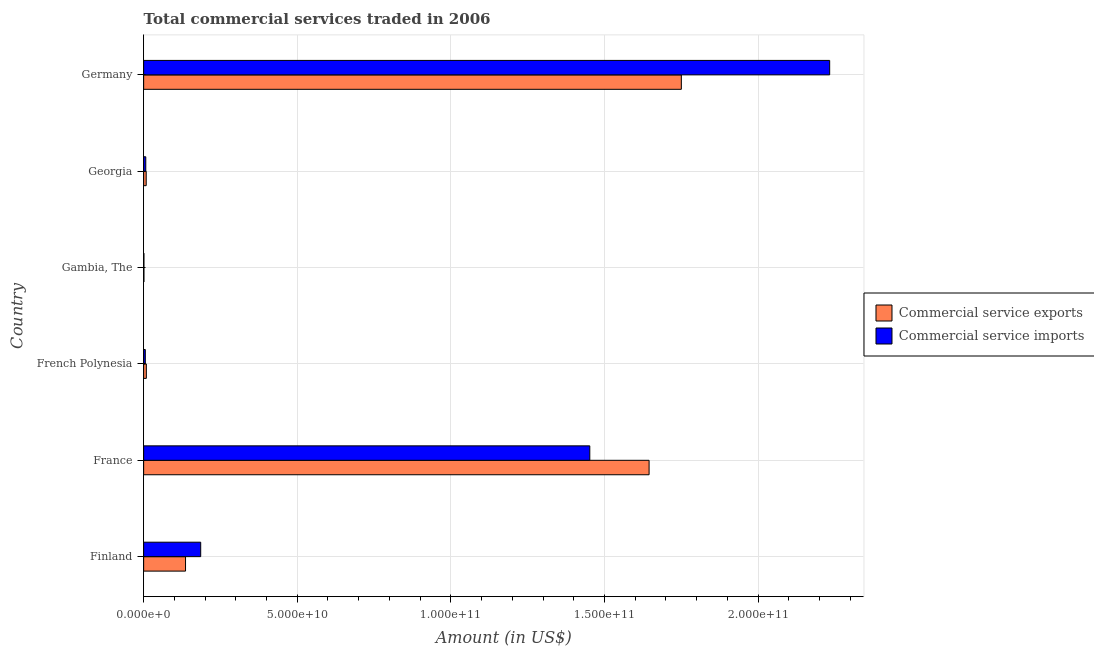How many groups of bars are there?
Your response must be concise. 6. Are the number of bars per tick equal to the number of legend labels?
Your answer should be very brief. Yes. How many bars are there on the 2nd tick from the bottom?
Offer a very short reply. 2. What is the label of the 4th group of bars from the top?
Keep it short and to the point. French Polynesia. In how many cases, is the number of bars for a given country not equal to the number of legend labels?
Offer a terse response. 0. What is the amount of commercial service exports in Germany?
Offer a terse response. 1.75e+11. Across all countries, what is the maximum amount of commercial service imports?
Provide a succinct answer. 2.23e+11. Across all countries, what is the minimum amount of commercial service imports?
Offer a very short reply. 9.41e+07. In which country was the amount of commercial service exports maximum?
Provide a succinct answer. Germany. In which country was the amount of commercial service imports minimum?
Make the answer very short. Gambia, The. What is the total amount of commercial service imports in the graph?
Your response must be concise. 3.88e+11. What is the difference between the amount of commercial service exports in French Polynesia and that in Gambia, The?
Ensure brevity in your answer.  7.84e+08. What is the difference between the amount of commercial service imports in Gambia, The and the amount of commercial service exports in France?
Your response must be concise. -1.64e+11. What is the average amount of commercial service imports per country?
Offer a terse response. 6.47e+1. What is the difference between the amount of commercial service exports and amount of commercial service imports in France?
Provide a succinct answer. 1.93e+1. What is the ratio of the amount of commercial service exports in Finland to that in French Polynesia?
Ensure brevity in your answer.  15.57. What is the difference between the highest and the second highest amount of commercial service imports?
Provide a short and direct response. 7.81e+1. What is the difference between the highest and the lowest amount of commercial service imports?
Ensure brevity in your answer.  2.23e+11. What does the 2nd bar from the top in Finland represents?
Your answer should be compact. Commercial service exports. What does the 2nd bar from the bottom in Georgia represents?
Keep it short and to the point. Commercial service imports. How many bars are there?
Ensure brevity in your answer.  12. Are all the bars in the graph horizontal?
Give a very brief answer. Yes. How many countries are there in the graph?
Keep it short and to the point. 6. What is the difference between two consecutive major ticks on the X-axis?
Give a very brief answer. 5.00e+1. Are the values on the major ticks of X-axis written in scientific E-notation?
Your answer should be very brief. Yes. Does the graph contain any zero values?
Ensure brevity in your answer.  No. Does the graph contain grids?
Offer a very short reply. Yes. How are the legend labels stacked?
Your answer should be very brief. Vertical. What is the title of the graph?
Make the answer very short. Total commercial services traded in 2006. Does "Male population" appear as one of the legend labels in the graph?
Your answer should be compact. No. What is the Amount (in US$) in Commercial service exports in Finland?
Give a very brief answer. 1.36e+1. What is the Amount (in US$) of Commercial service imports in Finland?
Offer a terse response. 1.86e+1. What is the Amount (in US$) of Commercial service exports in France?
Your answer should be very brief. 1.65e+11. What is the Amount (in US$) of Commercial service imports in France?
Your response must be concise. 1.45e+11. What is the Amount (in US$) in Commercial service exports in French Polynesia?
Your answer should be compact. 8.76e+08. What is the Amount (in US$) in Commercial service imports in French Polynesia?
Offer a terse response. 5.42e+08. What is the Amount (in US$) of Commercial service exports in Gambia, The?
Your answer should be very brief. 9.21e+07. What is the Amount (in US$) of Commercial service imports in Gambia, The?
Offer a very short reply. 9.41e+07. What is the Amount (in US$) of Commercial service exports in Georgia?
Provide a succinct answer. 8.29e+08. What is the Amount (in US$) in Commercial service imports in Georgia?
Offer a very short reply. 6.93e+08. What is the Amount (in US$) in Commercial service exports in Germany?
Offer a very short reply. 1.75e+11. What is the Amount (in US$) in Commercial service imports in Germany?
Provide a short and direct response. 2.23e+11. Across all countries, what is the maximum Amount (in US$) in Commercial service exports?
Provide a short and direct response. 1.75e+11. Across all countries, what is the maximum Amount (in US$) in Commercial service imports?
Your answer should be compact. 2.23e+11. Across all countries, what is the minimum Amount (in US$) of Commercial service exports?
Provide a short and direct response. 9.21e+07. Across all countries, what is the minimum Amount (in US$) of Commercial service imports?
Make the answer very short. 9.41e+07. What is the total Amount (in US$) in Commercial service exports in the graph?
Offer a terse response. 3.55e+11. What is the total Amount (in US$) of Commercial service imports in the graph?
Keep it short and to the point. 3.88e+11. What is the difference between the Amount (in US$) of Commercial service exports in Finland and that in France?
Keep it short and to the point. -1.51e+11. What is the difference between the Amount (in US$) in Commercial service imports in Finland and that in France?
Your answer should be compact. -1.27e+11. What is the difference between the Amount (in US$) in Commercial service exports in Finland and that in French Polynesia?
Provide a short and direct response. 1.28e+1. What is the difference between the Amount (in US$) of Commercial service imports in Finland and that in French Polynesia?
Your answer should be very brief. 1.80e+1. What is the difference between the Amount (in US$) of Commercial service exports in Finland and that in Gambia, The?
Offer a terse response. 1.35e+1. What is the difference between the Amount (in US$) of Commercial service imports in Finland and that in Gambia, The?
Offer a very short reply. 1.85e+1. What is the difference between the Amount (in US$) in Commercial service exports in Finland and that in Georgia?
Your answer should be very brief. 1.28e+1. What is the difference between the Amount (in US$) of Commercial service imports in Finland and that in Georgia?
Keep it short and to the point. 1.79e+1. What is the difference between the Amount (in US$) in Commercial service exports in Finland and that in Germany?
Your answer should be compact. -1.61e+11. What is the difference between the Amount (in US$) in Commercial service imports in Finland and that in Germany?
Provide a short and direct response. -2.05e+11. What is the difference between the Amount (in US$) of Commercial service exports in France and that in French Polynesia?
Your answer should be very brief. 1.64e+11. What is the difference between the Amount (in US$) of Commercial service imports in France and that in French Polynesia?
Offer a terse response. 1.45e+11. What is the difference between the Amount (in US$) of Commercial service exports in France and that in Gambia, The?
Make the answer very short. 1.64e+11. What is the difference between the Amount (in US$) of Commercial service imports in France and that in Gambia, The?
Provide a short and direct response. 1.45e+11. What is the difference between the Amount (in US$) in Commercial service exports in France and that in Georgia?
Keep it short and to the point. 1.64e+11. What is the difference between the Amount (in US$) of Commercial service imports in France and that in Georgia?
Provide a succinct answer. 1.45e+11. What is the difference between the Amount (in US$) of Commercial service exports in France and that in Germany?
Keep it short and to the point. -1.05e+1. What is the difference between the Amount (in US$) of Commercial service imports in France and that in Germany?
Make the answer very short. -7.81e+1. What is the difference between the Amount (in US$) in Commercial service exports in French Polynesia and that in Gambia, The?
Make the answer very short. 7.84e+08. What is the difference between the Amount (in US$) in Commercial service imports in French Polynesia and that in Gambia, The?
Your answer should be compact. 4.48e+08. What is the difference between the Amount (in US$) in Commercial service exports in French Polynesia and that in Georgia?
Keep it short and to the point. 4.66e+07. What is the difference between the Amount (in US$) of Commercial service imports in French Polynesia and that in Georgia?
Offer a terse response. -1.51e+08. What is the difference between the Amount (in US$) of Commercial service exports in French Polynesia and that in Germany?
Keep it short and to the point. -1.74e+11. What is the difference between the Amount (in US$) in Commercial service imports in French Polynesia and that in Germany?
Your answer should be very brief. -2.23e+11. What is the difference between the Amount (in US$) in Commercial service exports in Gambia, The and that in Georgia?
Your answer should be very brief. -7.37e+08. What is the difference between the Amount (in US$) in Commercial service imports in Gambia, The and that in Georgia?
Provide a succinct answer. -5.99e+08. What is the difference between the Amount (in US$) of Commercial service exports in Gambia, The and that in Germany?
Your answer should be very brief. -1.75e+11. What is the difference between the Amount (in US$) in Commercial service imports in Gambia, The and that in Germany?
Your answer should be very brief. -2.23e+11. What is the difference between the Amount (in US$) of Commercial service exports in Georgia and that in Germany?
Ensure brevity in your answer.  -1.74e+11. What is the difference between the Amount (in US$) of Commercial service imports in Georgia and that in Germany?
Offer a terse response. -2.23e+11. What is the difference between the Amount (in US$) in Commercial service exports in Finland and the Amount (in US$) in Commercial service imports in France?
Keep it short and to the point. -1.32e+11. What is the difference between the Amount (in US$) of Commercial service exports in Finland and the Amount (in US$) of Commercial service imports in French Polynesia?
Offer a terse response. 1.31e+1. What is the difference between the Amount (in US$) in Commercial service exports in Finland and the Amount (in US$) in Commercial service imports in Gambia, The?
Your answer should be very brief. 1.35e+1. What is the difference between the Amount (in US$) in Commercial service exports in Finland and the Amount (in US$) in Commercial service imports in Georgia?
Provide a succinct answer. 1.29e+1. What is the difference between the Amount (in US$) in Commercial service exports in Finland and the Amount (in US$) in Commercial service imports in Germany?
Keep it short and to the point. -2.10e+11. What is the difference between the Amount (in US$) of Commercial service exports in France and the Amount (in US$) of Commercial service imports in French Polynesia?
Make the answer very short. 1.64e+11. What is the difference between the Amount (in US$) of Commercial service exports in France and the Amount (in US$) of Commercial service imports in Gambia, The?
Make the answer very short. 1.64e+11. What is the difference between the Amount (in US$) of Commercial service exports in France and the Amount (in US$) of Commercial service imports in Georgia?
Your response must be concise. 1.64e+11. What is the difference between the Amount (in US$) in Commercial service exports in France and the Amount (in US$) in Commercial service imports in Germany?
Keep it short and to the point. -5.88e+1. What is the difference between the Amount (in US$) of Commercial service exports in French Polynesia and the Amount (in US$) of Commercial service imports in Gambia, The?
Your answer should be compact. 7.82e+08. What is the difference between the Amount (in US$) in Commercial service exports in French Polynesia and the Amount (in US$) in Commercial service imports in Georgia?
Offer a terse response. 1.83e+08. What is the difference between the Amount (in US$) of Commercial service exports in French Polynesia and the Amount (in US$) of Commercial service imports in Germany?
Ensure brevity in your answer.  -2.22e+11. What is the difference between the Amount (in US$) of Commercial service exports in Gambia, The and the Amount (in US$) of Commercial service imports in Georgia?
Your answer should be compact. -6.01e+08. What is the difference between the Amount (in US$) in Commercial service exports in Gambia, The and the Amount (in US$) in Commercial service imports in Germany?
Your answer should be very brief. -2.23e+11. What is the difference between the Amount (in US$) in Commercial service exports in Georgia and the Amount (in US$) in Commercial service imports in Germany?
Give a very brief answer. -2.22e+11. What is the average Amount (in US$) of Commercial service exports per country?
Offer a very short reply. 5.92e+1. What is the average Amount (in US$) in Commercial service imports per country?
Your answer should be compact. 6.47e+1. What is the difference between the Amount (in US$) in Commercial service exports and Amount (in US$) in Commercial service imports in Finland?
Provide a short and direct response. -4.93e+09. What is the difference between the Amount (in US$) of Commercial service exports and Amount (in US$) of Commercial service imports in France?
Provide a succinct answer. 1.93e+1. What is the difference between the Amount (in US$) in Commercial service exports and Amount (in US$) in Commercial service imports in French Polynesia?
Offer a terse response. 3.34e+08. What is the difference between the Amount (in US$) of Commercial service exports and Amount (in US$) of Commercial service imports in Gambia, The?
Your answer should be very brief. -2.00e+06. What is the difference between the Amount (in US$) in Commercial service exports and Amount (in US$) in Commercial service imports in Georgia?
Make the answer very short. 1.36e+08. What is the difference between the Amount (in US$) in Commercial service exports and Amount (in US$) in Commercial service imports in Germany?
Provide a short and direct response. -4.83e+1. What is the ratio of the Amount (in US$) in Commercial service exports in Finland to that in France?
Your response must be concise. 0.08. What is the ratio of the Amount (in US$) in Commercial service imports in Finland to that in France?
Offer a very short reply. 0.13. What is the ratio of the Amount (in US$) in Commercial service exports in Finland to that in French Polynesia?
Your answer should be very brief. 15.57. What is the ratio of the Amount (in US$) in Commercial service imports in Finland to that in French Polynesia?
Provide a short and direct response. 34.25. What is the ratio of the Amount (in US$) of Commercial service exports in Finland to that in Gambia, The?
Make the answer very short. 148.09. What is the ratio of the Amount (in US$) in Commercial service imports in Finland to that in Gambia, The?
Provide a short and direct response. 197.4. What is the ratio of the Amount (in US$) in Commercial service exports in Finland to that in Georgia?
Provide a succinct answer. 16.44. What is the ratio of the Amount (in US$) of Commercial service imports in Finland to that in Georgia?
Give a very brief answer. 26.79. What is the ratio of the Amount (in US$) in Commercial service exports in Finland to that in Germany?
Your answer should be compact. 0.08. What is the ratio of the Amount (in US$) in Commercial service imports in Finland to that in Germany?
Your answer should be very brief. 0.08. What is the ratio of the Amount (in US$) in Commercial service exports in France to that in French Polynesia?
Ensure brevity in your answer.  187.82. What is the ratio of the Amount (in US$) of Commercial service imports in France to that in French Polynesia?
Provide a short and direct response. 267.83. What is the ratio of the Amount (in US$) in Commercial service exports in France to that in Gambia, The?
Give a very brief answer. 1786.83. What is the ratio of the Amount (in US$) of Commercial service imports in France to that in Gambia, The?
Provide a succinct answer. 1543.76. What is the ratio of the Amount (in US$) in Commercial service exports in France to that in Georgia?
Keep it short and to the point. 198.36. What is the ratio of the Amount (in US$) of Commercial service imports in France to that in Georgia?
Offer a very short reply. 209.51. What is the ratio of the Amount (in US$) in Commercial service exports in France to that in Germany?
Make the answer very short. 0.94. What is the ratio of the Amount (in US$) of Commercial service imports in France to that in Germany?
Provide a short and direct response. 0.65. What is the ratio of the Amount (in US$) in Commercial service exports in French Polynesia to that in Gambia, The?
Your answer should be very brief. 9.51. What is the ratio of the Amount (in US$) in Commercial service imports in French Polynesia to that in Gambia, The?
Your answer should be very brief. 5.76. What is the ratio of the Amount (in US$) in Commercial service exports in French Polynesia to that in Georgia?
Provide a succinct answer. 1.06. What is the ratio of the Amount (in US$) of Commercial service imports in French Polynesia to that in Georgia?
Provide a short and direct response. 0.78. What is the ratio of the Amount (in US$) of Commercial service exports in French Polynesia to that in Germany?
Ensure brevity in your answer.  0.01. What is the ratio of the Amount (in US$) of Commercial service imports in French Polynesia to that in Germany?
Offer a very short reply. 0. What is the ratio of the Amount (in US$) of Commercial service exports in Gambia, The to that in Georgia?
Ensure brevity in your answer.  0.11. What is the ratio of the Amount (in US$) of Commercial service imports in Gambia, The to that in Georgia?
Offer a very short reply. 0.14. What is the ratio of the Amount (in US$) in Commercial service exports in Gambia, The to that in Germany?
Your response must be concise. 0. What is the ratio of the Amount (in US$) of Commercial service exports in Georgia to that in Germany?
Provide a succinct answer. 0. What is the ratio of the Amount (in US$) in Commercial service imports in Georgia to that in Germany?
Keep it short and to the point. 0. What is the difference between the highest and the second highest Amount (in US$) of Commercial service exports?
Provide a succinct answer. 1.05e+1. What is the difference between the highest and the second highest Amount (in US$) of Commercial service imports?
Make the answer very short. 7.81e+1. What is the difference between the highest and the lowest Amount (in US$) in Commercial service exports?
Offer a very short reply. 1.75e+11. What is the difference between the highest and the lowest Amount (in US$) in Commercial service imports?
Give a very brief answer. 2.23e+11. 